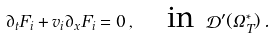Convert formula to latex. <formula><loc_0><loc_0><loc_500><loc_500>\partial _ { t } F _ { i } + v _ { i } \partial _ { x } F _ { i } = 0 \, , \quad \text {in} \ \mathcal { D } ^ { \prime } ( \Omega _ { T } ^ { * } ) \, .</formula> 